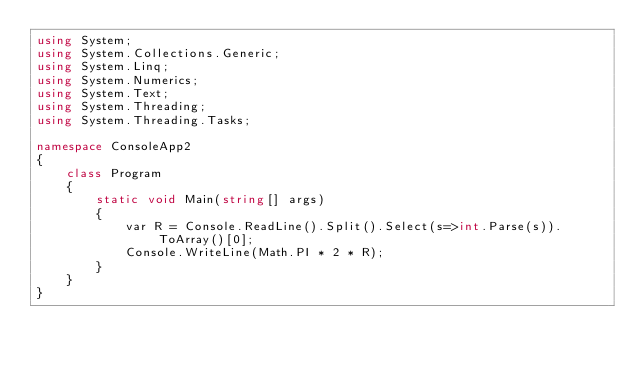<code> <loc_0><loc_0><loc_500><loc_500><_C#_>using System;
using System.Collections.Generic;
using System.Linq;
using System.Numerics;
using System.Text;
using System.Threading;
using System.Threading.Tasks;
 
namespace ConsoleApp2
{
    class Program
    {
        static void Main(string[] args)
        {
            var R = Console.ReadLine().Split().Select(s=>int.Parse(s)).ToArray()[0];
            Console.WriteLine(Math.PI * 2 * R);
        }
    }
}</code> 